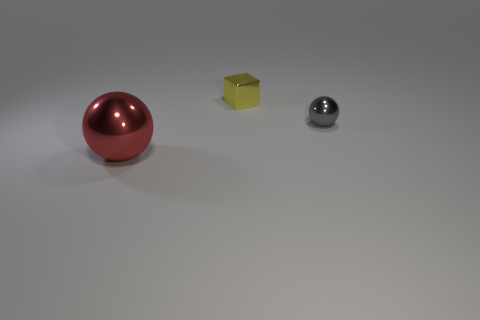Add 1 tiny gray metal things. How many objects exist? 4 Subtract all cubes. How many objects are left? 2 Subtract all large red balls. Subtract all yellow metal things. How many objects are left? 1 Add 1 big spheres. How many big spheres are left? 2 Add 3 tiny green objects. How many tiny green objects exist? 3 Subtract 0 purple cubes. How many objects are left? 3 